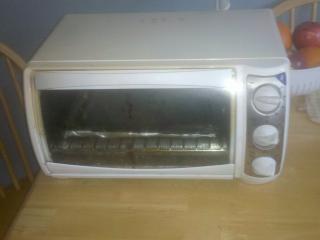How many racks in oven?
Give a very brief answer. 1. How many boats are in the water?
Give a very brief answer. 0. 